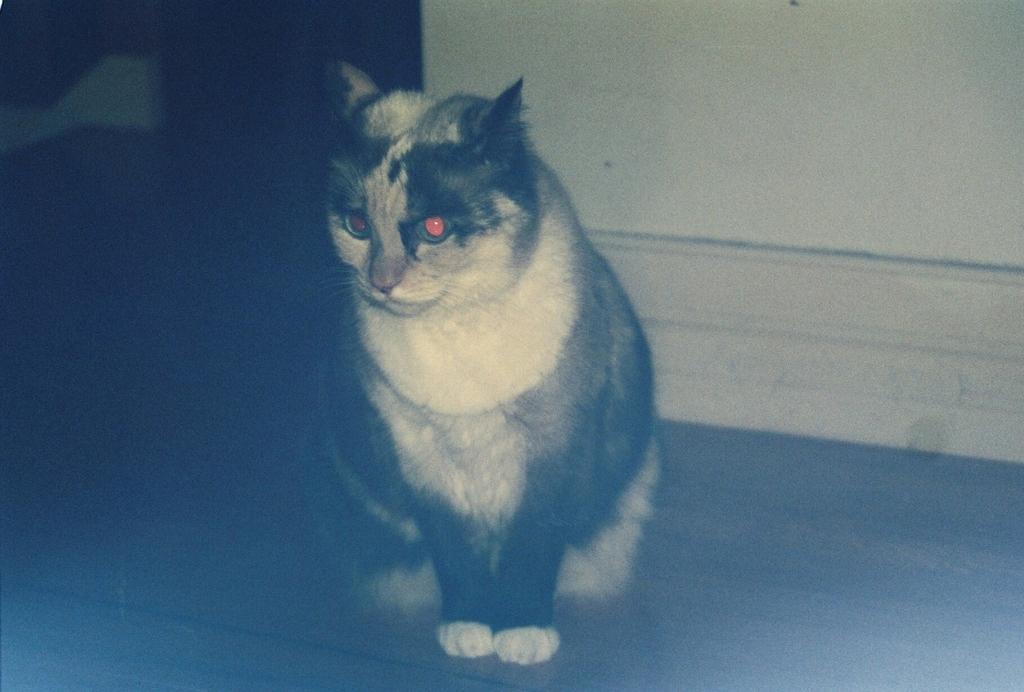How would you summarize this image in a sentence or two? In this image we can see a cat on the floor, at back here is the wall. 